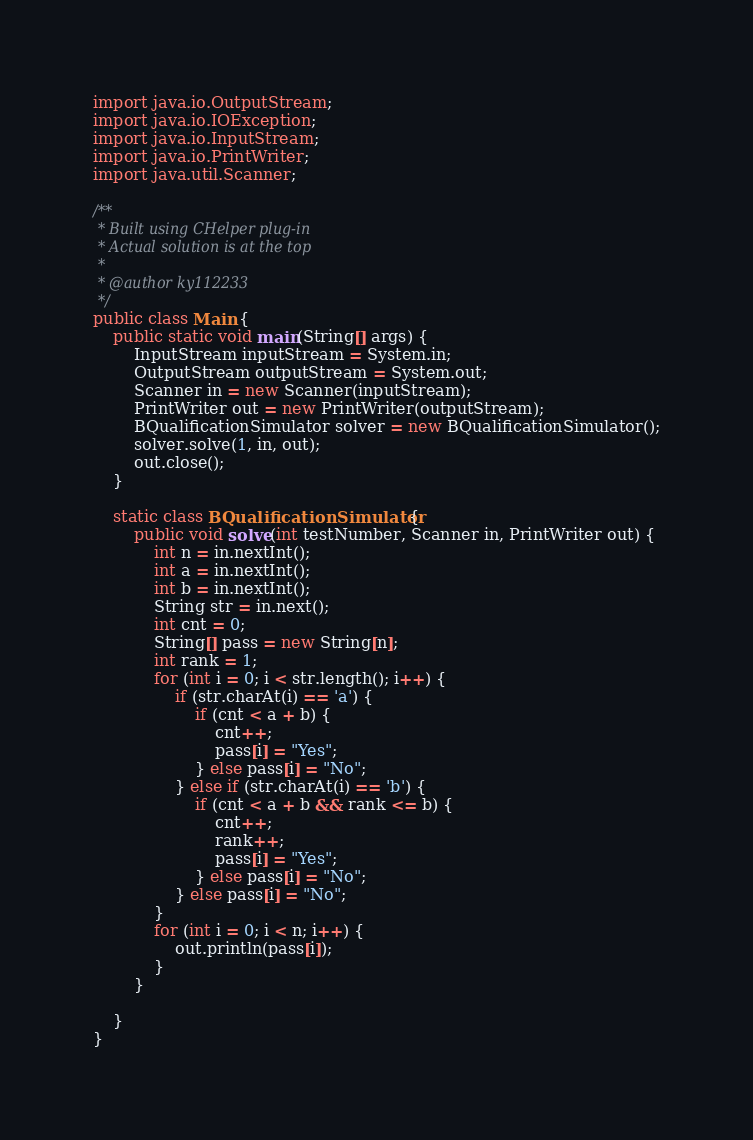Convert code to text. <code><loc_0><loc_0><loc_500><loc_500><_Java_>import java.io.OutputStream;
import java.io.IOException;
import java.io.InputStream;
import java.io.PrintWriter;
import java.util.Scanner;

/**
 * Built using CHelper plug-in
 * Actual solution is at the top
 *
 * @author ky112233
 */
public class Main {
    public static void main(String[] args) {
        InputStream inputStream = System.in;
        OutputStream outputStream = System.out;
        Scanner in = new Scanner(inputStream);
        PrintWriter out = new PrintWriter(outputStream);
        BQualificationSimulator solver = new BQualificationSimulator();
        solver.solve(1, in, out);
        out.close();
    }

    static class BQualificationSimulator {
        public void solve(int testNumber, Scanner in, PrintWriter out) {
            int n = in.nextInt();
            int a = in.nextInt();
            int b = in.nextInt();
            String str = in.next();
            int cnt = 0;
            String[] pass = new String[n];
            int rank = 1;
            for (int i = 0; i < str.length(); i++) {
                if (str.charAt(i) == 'a') {
                    if (cnt < a + b) {
                        cnt++;
                        pass[i] = "Yes";
                    } else pass[i] = "No";
                } else if (str.charAt(i) == 'b') {
                    if (cnt < a + b && rank <= b) {
                        cnt++;
                        rank++;
                        pass[i] = "Yes";
                    } else pass[i] = "No";
                } else pass[i] = "No";
            }
            for (int i = 0; i < n; i++) {
                out.println(pass[i]);
            }
        }

    }
}

</code> 